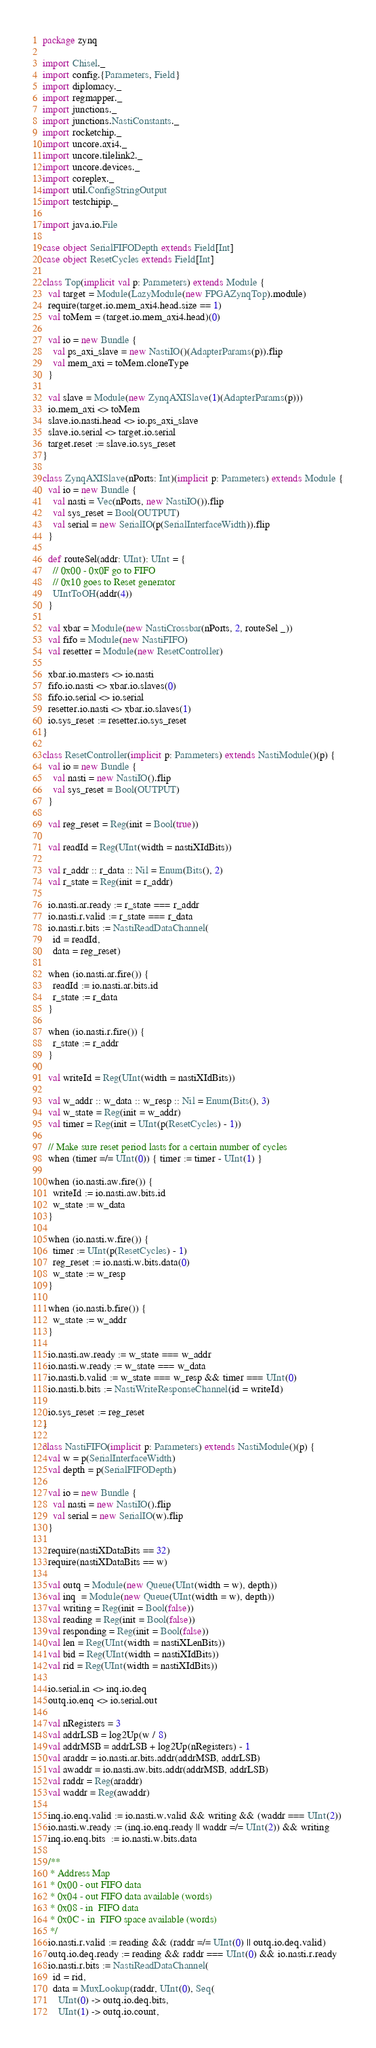<code> <loc_0><loc_0><loc_500><loc_500><_Scala_>
package zynq

import Chisel._
import config.{Parameters, Field}
import diplomacy._
import regmapper._
import junctions._
import junctions.NastiConstants._
import rocketchip._
import uncore.axi4._
import uncore.tilelink2._
import uncore.devices._
import coreplex._
import util.ConfigStringOutput
import testchipip._

import java.io.File

case object SerialFIFODepth extends Field[Int]
case object ResetCycles extends Field[Int]

class Top(implicit val p: Parameters) extends Module {
  val target = Module(LazyModule(new FPGAZynqTop).module)
  require(target.io.mem_axi4.head.size == 1)
  val toMem = (target.io.mem_axi4.head)(0)

  val io = new Bundle {
    val ps_axi_slave = new NastiIO()(AdapterParams(p)).flip
    val mem_axi = toMem.cloneType
  }

  val slave = Module(new ZynqAXISlave(1)(AdapterParams(p)))
  io.mem_axi <> toMem
  slave.io.nasti.head <> io.ps_axi_slave
  slave.io.serial <> target.io.serial
  target.reset := slave.io.sys_reset
}

class ZynqAXISlave(nPorts: Int)(implicit p: Parameters) extends Module {
  val io = new Bundle {
    val nasti = Vec(nPorts, new NastiIO()).flip
    val sys_reset = Bool(OUTPUT)
    val serial = new SerialIO(p(SerialInterfaceWidth)).flip
  }

  def routeSel(addr: UInt): UInt = {
    // 0x00 - 0x0F go to FIFO
    // 0x10 goes to Reset generator
    UIntToOH(addr(4))
  }

  val xbar = Module(new NastiCrossbar(nPorts, 2, routeSel _))
  val fifo = Module(new NastiFIFO)
  val resetter = Module(new ResetController)

  xbar.io.masters <> io.nasti
  fifo.io.nasti <> xbar.io.slaves(0)
  fifo.io.serial <> io.serial
  resetter.io.nasti <> xbar.io.slaves(1)
  io.sys_reset := resetter.io.sys_reset
}

class ResetController(implicit p: Parameters) extends NastiModule()(p) {
  val io = new Bundle {
    val nasti = new NastiIO().flip
    val sys_reset = Bool(OUTPUT)
  }

  val reg_reset = Reg(init = Bool(true))

  val readId = Reg(UInt(width = nastiXIdBits))

  val r_addr :: r_data :: Nil = Enum(Bits(), 2)
  val r_state = Reg(init = r_addr)

  io.nasti.ar.ready := r_state === r_addr
  io.nasti.r.valid := r_state === r_data
  io.nasti.r.bits := NastiReadDataChannel(
    id = readId,
    data = reg_reset)

  when (io.nasti.ar.fire()) {
    readId := io.nasti.ar.bits.id
    r_state := r_data
  }

  when (io.nasti.r.fire()) {
    r_state := r_addr
  }

  val writeId = Reg(UInt(width = nastiXIdBits))

  val w_addr :: w_data :: w_resp :: Nil = Enum(Bits(), 3)
  val w_state = Reg(init = w_addr)
  val timer = Reg(init = UInt(p(ResetCycles) - 1))

  // Make sure reset period lasts for a certain number of cycles
  when (timer =/= UInt(0)) { timer := timer - UInt(1) }

  when (io.nasti.aw.fire()) {
    writeId := io.nasti.aw.bits.id
    w_state := w_data
  }

  when (io.nasti.w.fire()) {
    timer := UInt(p(ResetCycles) - 1)
    reg_reset := io.nasti.w.bits.data(0)
    w_state := w_resp
  }

  when (io.nasti.b.fire()) {
    w_state := w_addr
  }

  io.nasti.aw.ready := w_state === w_addr
  io.nasti.w.ready := w_state === w_data
  io.nasti.b.valid := w_state === w_resp && timer === UInt(0)
  io.nasti.b.bits := NastiWriteResponseChannel(id = writeId)

  io.sys_reset := reg_reset
}

class NastiFIFO(implicit p: Parameters) extends NastiModule()(p) {
  val w = p(SerialInterfaceWidth)
  val depth = p(SerialFIFODepth)

  val io = new Bundle {
    val nasti = new NastiIO().flip
    val serial = new SerialIO(w).flip
  }

  require(nastiXDataBits == 32)
  require(nastiXDataBits == w)

  val outq = Module(new Queue(UInt(width = w), depth))
  val inq  = Module(new Queue(UInt(width = w), depth))
  val writing = Reg(init = Bool(false))
  val reading = Reg(init = Bool(false))
  val responding = Reg(init = Bool(false))
  val len = Reg(UInt(width = nastiXLenBits))
  val bid = Reg(UInt(width = nastiXIdBits))
  val rid = Reg(UInt(width = nastiXIdBits))

  io.serial.in <> inq.io.deq
  outq.io.enq <> io.serial.out

  val nRegisters = 3
  val addrLSB = log2Up(w / 8)
  val addrMSB = addrLSB + log2Up(nRegisters) - 1
  val araddr = io.nasti.ar.bits.addr(addrMSB, addrLSB)
  val awaddr = io.nasti.aw.bits.addr(addrMSB, addrLSB)
  val raddr = Reg(araddr)
  val waddr = Reg(awaddr)

  inq.io.enq.valid := io.nasti.w.valid && writing && (waddr === UInt(2))
  io.nasti.w.ready := (inq.io.enq.ready || waddr =/= UInt(2)) && writing
  inq.io.enq.bits  := io.nasti.w.bits.data

  /**
   * Address Map
   * 0x00 - out FIFO data
   * 0x04 - out FIFO data available (words)
   * 0x08 - in  FIFO data
   * 0x0C - in  FIFO space available (words)
   */
  io.nasti.r.valid := reading && (raddr =/= UInt(0) || outq.io.deq.valid)
  outq.io.deq.ready := reading && raddr === UInt(0) && io.nasti.r.ready
  io.nasti.r.bits := NastiReadDataChannel(
    id = rid,
    data = MuxLookup(raddr, UInt(0), Seq(
      UInt(0) -> outq.io.deq.bits,
      UInt(1) -> outq.io.count,</code> 